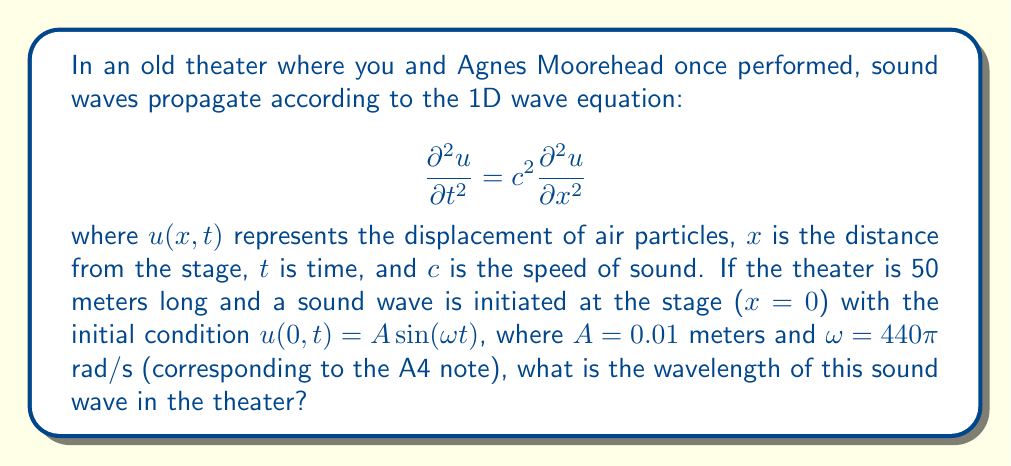Provide a solution to this math problem. To solve this problem, we'll follow these steps:

1) First, recall that the angular frequency $\omega$ is related to the frequency $f$ by:
   $$\omega = 2\pi f$$

2) We can solve for $f$:
   $$f = \frac{\omega}{2\pi} = \frac{440\pi}{2\pi} = 220\text{ Hz}$$

3) The speed of sound $c$ in air at room temperature is approximately 343 m/s.

4) Now, we can use the wave equation to relate wavelength $\lambda$, frequency $f$, and wave speed $c$:
   $$c = \lambda f$$

5) Solving for $\lambda$:
   $$\lambda = \frac{c}{f} = \frac{343\text{ m/s}}{220\text{ Hz}} = 1.56\text{ m}$$

Thus, the wavelength of the A4 note in the theater is approximately 1.56 meters.
Answer: $1.56\text{ m}$ 